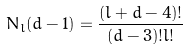<formula> <loc_0><loc_0><loc_500><loc_500>N _ { l } ( d - 1 ) = \frac { ( l + d - 4 ) ! } { ( d - 3 ) ! l ! }</formula> 